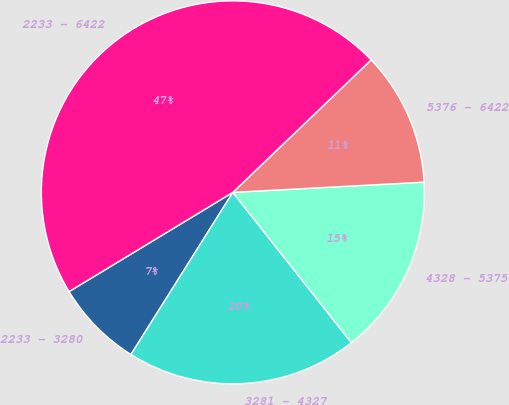<chart> <loc_0><loc_0><loc_500><loc_500><pie_chart><fcel>2233 - 3280<fcel>3281 - 4327<fcel>4328 - 5375<fcel>5376 - 6422<fcel>2233 - 6422<nl><fcel>7.4%<fcel>19.56%<fcel>15.22%<fcel>11.31%<fcel>46.51%<nl></chart> 